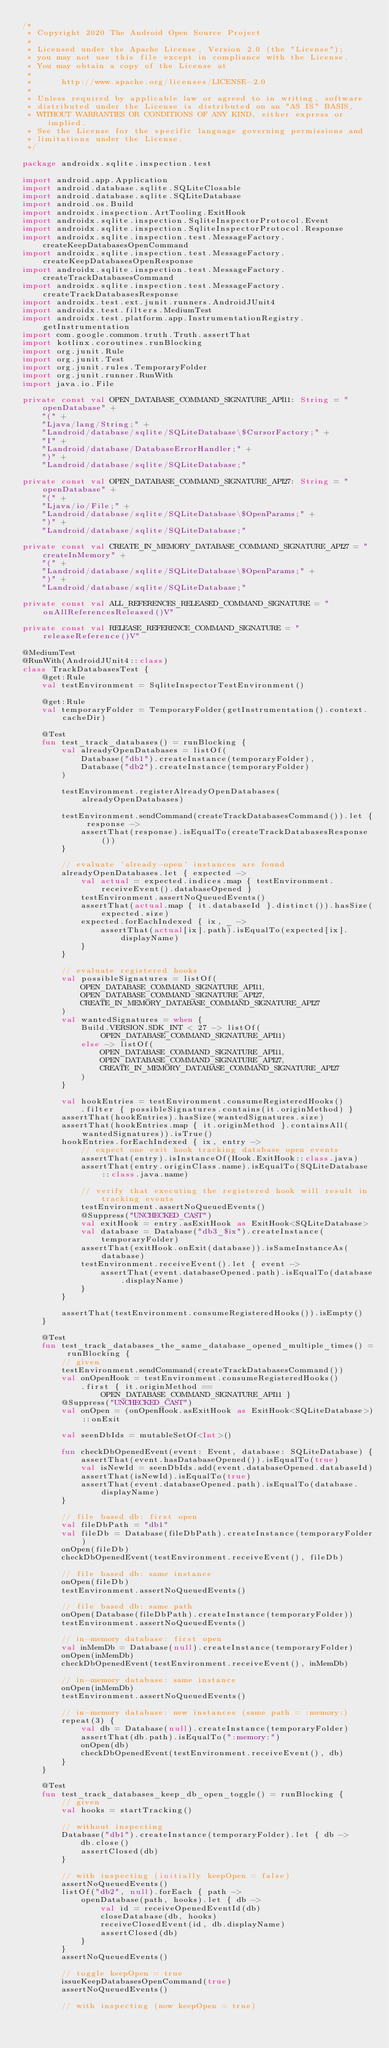<code> <loc_0><loc_0><loc_500><loc_500><_Kotlin_>/*
 * Copyright 2020 The Android Open Source Project
 *
 * Licensed under the Apache License, Version 2.0 (the "License");
 * you may not use this file except in compliance with the License.
 * You may obtain a copy of the License at
 *
 *      http://www.apache.org/licenses/LICENSE-2.0
 *
 * Unless required by applicable law or agreed to in writing, software
 * distributed under the License is distributed on an "AS IS" BASIS,
 * WITHOUT WARRANTIES OR CONDITIONS OF ANY KIND, either express or implied.
 * See the License for the specific language governing permissions and
 * limitations under the License.
 */

package androidx.sqlite.inspection.test

import android.app.Application
import android.database.sqlite.SQLiteClosable
import android.database.sqlite.SQLiteDatabase
import android.os.Build
import androidx.inspection.ArtTooling.ExitHook
import androidx.sqlite.inspection.SqliteInspectorProtocol.Event
import androidx.sqlite.inspection.SqliteInspectorProtocol.Response
import androidx.sqlite.inspection.test.MessageFactory.createKeepDatabasesOpenCommand
import androidx.sqlite.inspection.test.MessageFactory.createKeepDatabasesOpenResponse
import androidx.sqlite.inspection.test.MessageFactory.createTrackDatabasesCommand
import androidx.sqlite.inspection.test.MessageFactory.createTrackDatabasesResponse
import androidx.test.ext.junit.runners.AndroidJUnit4
import androidx.test.filters.MediumTest
import androidx.test.platform.app.InstrumentationRegistry.getInstrumentation
import com.google.common.truth.Truth.assertThat
import kotlinx.coroutines.runBlocking
import org.junit.Rule
import org.junit.Test
import org.junit.rules.TemporaryFolder
import org.junit.runner.RunWith
import java.io.File

private const val OPEN_DATABASE_COMMAND_SIGNATURE_API11: String = "openDatabase" +
    "(" +
    "Ljava/lang/String;" +
    "Landroid/database/sqlite/SQLiteDatabase\$CursorFactory;" +
    "I" +
    "Landroid/database/DatabaseErrorHandler;" +
    ")" +
    "Landroid/database/sqlite/SQLiteDatabase;"

private const val OPEN_DATABASE_COMMAND_SIGNATURE_API27: String = "openDatabase" +
    "(" +
    "Ljava/io/File;" +
    "Landroid/database/sqlite/SQLiteDatabase\$OpenParams;" +
    ")" +
    "Landroid/database/sqlite/SQLiteDatabase;"

private const val CREATE_IN_MEMORY_DATABASE_COMMAND_SIGNATURE_API27 = "createInMemory" +
    "(" +
    "Landroid/database/sqlite/SQLiteDatabase\$OpenParams;" +
    ")" +
    "Landroid/database/sqlite/SQLiteDatabase;"

private const val ALL_REFERENCES_RELEASED_COMMAND_SIGNATURE = "onAllReferencesReleased()V"

private const val RELEASE_REFERENCE_COMMAND_SIGNATURE = "releaseReference()V"

@MediumTest
@RunWith(AndroidJUnit4::class)
class TrackDatabasesTest {
    @get:Rule
    val testEnvironment = SqliteInspectorTestEnvironment()

    @get:Rule
    val temporaryFolder = TemporaryFolder(getInstrumentation().context.cacheDir)

    @Test
    fun test_track_databases() = runBlocking {
        val alreadyOpenDatabases = listOf(
            Database("db1").createInstance(temporaryFolder),
            Database("db2").createInstance(temporaryFolder)
        )

        testEnvironment.registerAlreadyOpenDatabases(alreadyOpenDatabases)

        testEnvironment.sendCommand(createTrackDatabasesCommand()).let { response ->
            assertThat(response).isEqualTo(createTrackDatabasesResponse())
        }

        // evaluate 'already-open' instances are found
        alreadyOpenDatabases.let { expected ->
            val actual = expected.indices.map { testEnvironment.receiveEvent().databaseOpened }
            testEnvironment.assertNoQueuedEvents()
            assertThat(actual.map { it.databaseId }.distinct()).hasSize(expected.size)
            expected.forEachIndexed { ix, _ ->
                assertThat(actual[ix].path).isEqualTo(expected[ix].displayName)
            }
        }

        // evaluate registered hooks
        val possibleSignatures = listOf(
            OPEN_DATABASE_COMMAND_SIGNATURE_API11,
            OPEN_DATABASE_COMMAND_SIGNATURE_API27,
            CREATE_IN_MEMORY_DATABASE_COMMAND_SIGNATURE_API27
        )
        val wantedSignatures = when {
            Build.VERSION.SDK_INT < 27 -> listOf(OPEN_DATABASE_COMMAND_SIGNATURE_API11)
            else -> listOf(
                OPEN_DATABASE_COMMAND_SIGNATURE_API11,
                OPEN_DATABASE_COMMAND_SIGNATURE_API27,
                CREATE_IN_MEMORY_DATABASE_COMMAND_SIGNATURE_API27
            )
        }

        val hookEntries = testEnvironment.consumeRegisteredHooks()
            .filter { possibleSignatures.contains(it.originMethod) }
        assertThat(hookEntries).hasSize(wantedSignatures.size)
        assertThat(hookEntries.map { it.originMethod }.containsAll(wantedSignatures)).isTrue()
        hookEntries.forEachIndexed { ix, entry ->
            // expect one exit hook tracking database open events
            assertThat(entry).isInstanceOf(Hook.ExitHook::class.java)
            assertThat(entry.originClass.name).isEqualTo(SQLiteDatabase::class.java.name)

            // verify that executing the registered hook will result in tracking events
            testEnvironment.assertNoQueuedEvents()
            @Suppress("UNCHECKED_CAST")
            val exitHook = entry.asExitHook as ExitHook<SQLiteDatabase>
            val database = Database("db3_$ix").createInstance(temporaryFolder)
            assertThat(exitHook.onExit(database)).isSameInstanceAs(database)
            testEnvironment.receiveEvent().let { event ->
                assertThat(event.databaseOpened.path).isEqualTo(database.displayName)
            }
        }

        assertThat(testEnvironment.consumeRegisteredHooks()).isEmpty()
    }

    @Test
    fun test_track_databases_the_same_database_opened_multiple_times() = runBlocking {
        // given
        testEnvironment.sendCommand(createTrackDatabasesCommand())
        val onOpenHook = testEnvironment.consumeRegisteredHooks()
            .first { it.originMethod == OPEN_DATABASE_COMMAND_SIGNATURE_API11 }
        @Suppress("UNCHECKED_CAST")
        val onOpen = (onOpenHook.asExitHook as ExitHook<SQLiteDatabase>)::onExit

        val seenDbIds = mutableSetOf<Int>()

        fun checkDbOpenedEvent(event: Event, database: SQLiteDatabase) {
            assertThat(event.hasDatabaseOpened()).isEqualTo(true)
            val isNewId = seenDbIds.add(event.databaseOpened.databaseId)
            assertThat(isNewId).isEqualTo(true)
            assertThat(event.databaseOpened.path).isEqualTo(database.displayName)
        }

        // file based db: first open
        val fileDbPath = "db1"
        val fileDb = Database(fileDbPath).createInstance(temporaryFolder)
        onOpen(fileDb)
        checkDbOpenedEvent(testEnvironment.receiveEvent(), fileDb)

        // file based db: same instance
        onOpen(fileDb)
        testEnvironment.assertNoQueuedEvents()

        // file based db: same path
        onOpen(Database(fileDbPath).createInstance(temporaryFolder))
        testEnvironment.assertNoQueuedEvents()

        // in-memory database: first open
        val inMemDb = Database(null).createInstance(temporaryFolder)
        onOpen(inMemDb)
        checkDbOpenedEvent(testEnvironment.receiveEvent(), inMemDb)

        // in-memory database: same instance
        onOpen(inMemDb)
        testEnvironment.assertNoQueuedEvents()

        // in-memory database: new instances (same path = :memory:)
        repeat(3) {
            val db = Database(null).createInstance(temporaryFolder)
            assertThat(db.path).isEqualTo(":memory:")
            onOpen(db)
            checkDbOpenedEvent(testEnvironment.receiveEvent(), db)
        }
    }

    @Test
    fun test_track_databases_keep_db_open_toggle() = runBlocking {
        // given
        val hooks = startTracking()

        // without inspecting
        Database("db1").createInstance(temporaryFolder).let { db ->
            db.close()
            assertClosed(db)
        }

        // with inspecting (initially keepOpen = false)
        assertNoQueuedEvents()
        listOf("db2", null).forEach { path ->
            openDatabase(path, hooks).let { db ->
                val id = receiveOpenedEventId(db)
                closeDatabase(db, hooks)
                receiveClosedEvent(id, db.displayName)
                assertClosed(db)
            }
        }
        assertNoQueuedEvents()

        // toggle keepOpen = true
        issueKeepDatabasesOpenCommand(true)
        assertNoQueuedEvents()

        // with inspecting (now keepOpen = true)</code> 